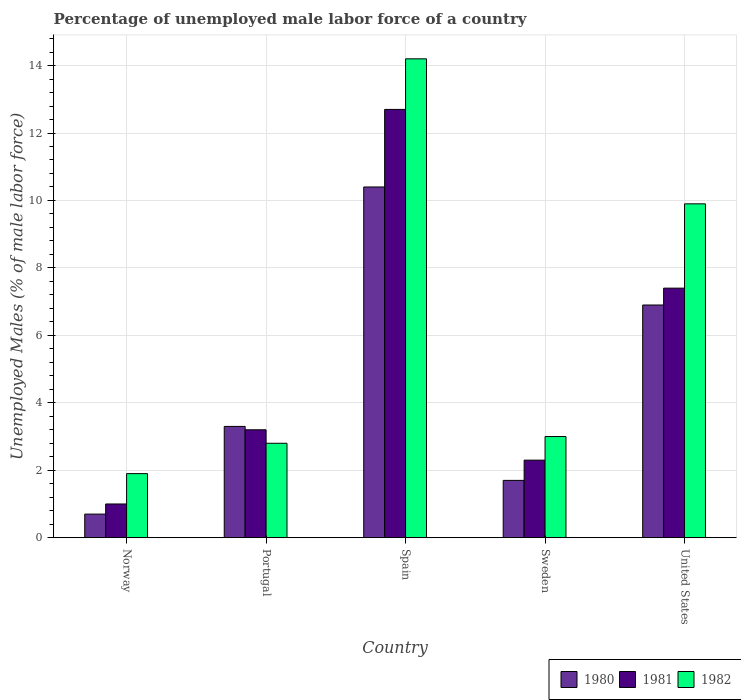How many bars are there on the 2nd tick from the right?
Your answer should be compact. 3. What is the label of the 3rd group of bars from the left?
Make the answer very short. Spain. In how many cases, is the number of bars for a given country not equal to the number of legend labels?
Offer a very short reply. 0. What is the percentage of unemployed male labor force in 1981 in Spain?
Give a very brief answer. 12.7. Across all countries, what is the maximum percentage of unemployed male labor force in 1982?
Your answer should be very brief. 14.2. Across all countries, what is the minimum percentage of unemployed male labor force in 1982?
Your answer should be compact. 1.9. In which country was the percentage of unemployed male labor force in 1981 maximum?
Offer a terse response. Spain. In which country was the percentage of unemployed male labor force in 1980 minimum?
Offer a very short reply. Norway. What is the total percentage of unemployed male labor force in 1982 in the graph?
Your answer should be very brief. 31.8. What is the difference between the percentage of unemployed male labor force in 1982 in Portugal and that in United States?
Your answer should be compact. -7.1. What is the difference between the percentage of unemployed male labor force in 1981 in Norway and the percentage of unemployed male labor force in 1982 in Sweden?
Give a very brief answer. -2. What is the average percentage of unemployed male labor force in 1980 per country?
Your answer should be very brief. 4.6. What is the difference between the percentage of unemployed male labor force of/in 1980 and percentage of unemployed male labor force of/in 1981 in Sweden?
Make the answer very short. -0.6. In how many countries, is the percentage of unemployed male labor force in 1982 greater than 2 %?
Your answer should be compact. 4. What is the ratio of the percentage of unemployed male labor force in 1980 in Spain to that in Sweden?
Your response must be concise. 6.12. Is the percentage of unemployed male labor force in 1981 in Sweden less than that in United States?
Make the answer very short. Yes. Is the difference between the percentage of unemployed male labor force in 1980 in Spain and United States greater than the difference between the percentage of unemployed male labor force in 1981 in Spain and United States?
Make the answer very short. No. What is the difference between the highest and the second highest percentage of unemployed male labor force in 1981?
Give a very brief answer. -9.5. What is the difference between the highest and the lowest percentage of unemployed male labor force in 1982?
Give a very brief answer. 12.3. In how many countries, is the percentage of unemployed male labor force in 1982 greater than the average percentage of unemployed male labor force in 1982 taken over all countries?
Your answer should be compact. 2. What does the 1st bar from the left in Spain represents?
Make the answer very short. 1980. How many bars are there?
Your answer should be very brief. 15. How many countries are there in the graph?
Your response must be concise. 5. Does the graph contain any zero values?
Your answer should be very brief. No. What is the title of the graph?
Keep it short and to the point. Percentage of unemployed male labor force of a country. Does "1987" appear as one of the legend labels in the graph?
Provide a short and direct response. No. What is the label or title of the X-axis?
Make the answer very short. Country. What is the label or title of the Y-axis?
Provide a short and direct response. Unemployed Males (% of male labor force). What is the Unemployed Males (% of male labor force) in 1980 in Norway?
Your answer should be very brief. 0.7. What is the Unemployed Males (% of male labor force) in 1981 in Norway?
Offer a terse response. 1. What is the Unemployed Males (% of male labor force) of 1982 in Norway?
Give a very brief answer. 1.9. What is the Unemployed Males (% of male labor force) in 1980 in Portugal?
Offer a very short reply. 3.3. What is the Unemployed Males (% of male labor force) in 1981 in Portugal?
Give a very brief answer. 3.2. What is the Unemployed Males (% of male labor force) of 1982 in Portugal?
Your answer should be very brief. 2.8. What is the Unemployed Males (% of male labor force) of 1980 in Spain?
Offer a terse response. 10.4. What is the Unemployed Males (% of male labor force) of 1981 in Spain?
Offer a very short reply. 12.7. What is the Unemployed Males (% of male labor force) of 1982 in Spain?
Your answer should be very brief. 14.2. What is the Unemployed Males (% of male labor force) in 1980 in Sweden?
Your answer should be compact. 1.7. What is the Unemployed Males (% of male labor force) in 1981 in Sweden?
Keep it short and to the point. 2.3. What is the Unemployed Males (% of male labor force) of 1982 in Sweden?
Your answer should be compact. 3. What is the Unemployed Males (% of male labor force) of 1980 in United States?
Keep it short and to the point. 6.9. What is the Unemployed Males (% of male labor force) in 1981 in United States?
Offer a very short reply. 7.4. What is the Unemployed Males (% of male labor force) in 1982 in United States?
Give a very brief answer. 9.9. Across all countries, what is the maximum Unemployed Males (% of male labor force) of 1980?
Offer a terse response. 10.4. Across all countries, what is the maximum Unemployed Males (% of male labor force) of 1981?
Your answer should be compact. 12.7. Across all countries, what is the maximum Unemployed Males (% of male labor force) in 1982?
Provide a succinct answer. 14.2. Across all countries, what is the minimum Unemployed Males (% of male labor force) in 1980?
Offer a terse response. 0.7. Across all countries, what is the minimum Unemployed Males (% of male labor force) of 1981?
Provide a succinct answer. 1. Across all countries, what is the minimum Unemployed Males (% of male labor force) in 1982?
Your answer should be very brief. 1.9. What is the total Unemployed Males (% of male labor force) of 1980 in the graph?
Keep it short and to the point. 23. What is the total Unemployed Males (% of male labor force) in 1981 in the graph?
Ensure brevity in your answer.  26.6. What is the total Unemployed Males (% of male labor force) of 1982 in the graph?
Ensure brevity in your answer.  31.8. What is the difference between the Unemployed Males (% of male labor force) of 1980 in Norway and that in Portugal?
Your answer should be very brief. -2.6. What is the difference between the Unemployed Males (% of male labor force) of 1981 in Norway and that in Portugal?
Give a very brief answer. -2.2. What is the difference between the Unemployed Males (% of male labor force) in 1982 in Norway and that in Portugal?
Give a very brief answer. -0.9. What is the difference between the Unemployed Males (% of male labor force) in 1980 in Norway and that in Spain?
Offer a terse response. -9.7. What is the difference between the Unemployed Males (% of male labor force) in 1981 in Norway and that in Spain?
Your answer should be very brief. -11.7. What is the difference between the Unemployed Males (% of male labor force) of 1982 in Norway and that in Spain?
Your answer should be very brief. -12.3. What is the difference between the Unemployed Males (% of male labor force) in 1980 in Norway and that in Sweden?
Offer a very short reply. -1. What is the difference between the Unemployed Males (% of male labor force) of 1982 in Norway and that in Sweden?
Provide a short and direct response. -1.1. What is the difference between the Unemployed Males (% of male labor force) in 1980 in Norway and that in United States?
Offer a very short reply. -6.2. What is the difference between the Unemployed Males (% of male labor force) in 1981 in Norway and that in United States?
Your answer should be very brief. -6.4. What is the difference between the Unemployed Males (% of male labor force) in 1982 in Norway and that in United States?
Ensure brevity in your answer.  -8. What is the difference between the Unemployed Males (% of male labor force) in 1980 in Portugal and that in Spain?
Your answer should be compact. -7.1. What is the difference between the Unemployed Males (% of male labor force) of 1981 in Portugal and that in Spain?
Your response must be concise. -9.5. What is the difference between the Unemployed Males (% of male labor force) in 1982 in Portugal and that in Sweden?
Provide a short and direct response. -0.2. What is the difference between the Unemployed Males (% of male labor force) in 1981 in Portugal and that in United States?
Give a very brief answer. -4.2. What is the difference between the Unemployed Males (% of male labor force) of 1982 in Portugal and that in United States?
Provide a short and direct response. -7.1. What is the difference between the Unemployed Males (% of male labor force) of 1982 in Spain and that in United States?
Offer a very short reply. 4.3. What is the difference between the Unemployed Males (% of male labor force) in 1982 in Sweden and that in United States?
Your answer should be compact. -6.9. What is the difference between the Unemployed Males (% of male labor force) of 1980 in Norway and the Unemployed Males (% of male labor force) of 1982 in Portugal?
Your response must be concise. -2.1. What is the difference between the Unemployed Males (% of male labor force) in 1981 in Norway and the Unemployed Males (% of male labor force) in 1982 in Portugal?
Your response must be concise. -1.8. What is the difference between the Unemployed Males (% of male labor force) in 1980 in Norway and the Unemployed Males (% of male labor force) in 1982 in Spain?
Keep it short and to the point. -13.5. What is the difference between the Unemployed Males (% of male labor force) of 1981 in Norway and the Unemployed Males (% of male labor force) of 1982 in Spain?
Provide a short and direct response. -13.2. What is the difference between the Unemployed Males (% of male labor force) in 1980 in Norway and the Unemployed Males (% of male labor force) in 1982 in Sweden?
Offer a very short reply. -2.3. What is the difference between the Unemployed Males (% of male labor force) of 1981 in Norway and the Unemployed Males (% of male labor force) of 1982 in Sweden?
Offer a very short reply. -2. What is the difference between the Unemployed Males (% of male labor force) of 1980 in Norway and the Unemployed Males (% of male labor force) of 1982 in United States?
Keep it short and to the point. -9.2. What is the difference between the Unemployed Males (% of male labor force) in 1980 in Portugal and the Unemployed Males (% of male labor force) in 1981 in Spain?
Your answer should be compact. -9.4. What is the difference between the Unemployed Males (% of male labor force) in 1980 in Portugal and the Unemployed Males (% of male labor force) in 1981 in Sweden?
Keep it short and to the point. 1. What is the difference between the Unemployed Males (% of male labor force) of 1980 in Portugal and the Unemployed Males (% of male labor force) of 1982 in Sweden?
Provide a short and direct response. 0.3. What is the difference between the Unemployed Males (% of male labor force) in 1981 in Portugal and the Unemployed Males (% of male labor force) in 1982 in Sweden?
Your answer should be compact. 0.2. What is the difference between the Unemployed Males (% of male labor force) in 1980 in Portugal and the Unemployed Males (% of male labor force) in 1981 in United States?
Give a very brief answer. -4.1. What is the difference between the Unemployed Males (% of male labor force) in 1980 in Portugal and the Unemployed Males (% of male labor force) in 1982 in United States?
Keep it short and to the point. -6.6. What is the difference between the Unemployed Males (% of male labor force) of 1981 in Portugal and the Unemployed Males (% of male labor force) of 1982 in United States?
Provide a short and direct response. -6.7. What is the difference between the Unemployed Males (% of male labor force) of 1980 in Spain and the Unemployed Males (% of male labor force) of 1982 in Sweden?
Your answer should be very brief. 7.4. What is the difference between the Unemployed Males (% of male labor force) of 1981 in Spain and the Unemployed Males (% of male labor force) of 1982 in Sweden?
Your response must be concise. 9.7. What is the difference between the Unemployed Males (% of male labor force) in 1980 in Spain and the Unemployed Males (% of male labor force) in 1981 in United States?
Offer a very short reply. 3. What is the difference between the Unemployed Males (% of male labor force) of 1980 in Sweden and the Unemployed Males (% of male labor force) of 1981 in United States?
Give a very brief answer. -5.7. What is the difference between the Unemployed Males (% of male labor force) in 1981 in Sweden and the Unemployed Males (% of male labor force) in 1982 in United States?
Your answer should be compact. -7.6. What is the average Unemployed Males (% of male labor force) in 1981 per country?
Your response must be concise. 5.32. What is the average Unemployed Males (% of male labor force) in 1982 per country?
Your response must be concise. 6.36. What is the difference between the Unemployed Males (% of male labor force) of 1980 and Unemployed Males (% of male labor force) of 1982 in Norway?
Give a very brief answer. -1.2. What is the difference between the Unemployed Males (% of male labor force) in 1981 and Unemployed Males (% of male labor force) in 1982 in Portugal?
Keep it short and to the point. 0.4. What is the difference between the Unemployed Males (% of male labor force) in 1980 and Unemployed Males (% of male labor force) in 1982 in Spain?
Keep it short and to the point. -3.8. What is the difference between the Unemployed Males (% of male labor force) in 1981 and Unemployed Males (% of male labor force) in 1982 in Spain?
Offer a very short reply. -1.5. What is the difference between the Unemployed Males (% of male labor force) of 1980 and Unemployed Males (% of male labor force) of 1981 in Sweden?
Your answer should be very brief. -0.6. What is the difference between the Unemployed Males (% of male labor force) of 1981 and Unemployed Males (% of male labor force) of 1982 in Sweden?
Your answer should be compact. -0.7. What is the difference between the Unemployed Males (% of male labor force) of 1980 and Unemployed Males (% of male labor force) of 1982 in United States?
Make the answer very short. -3. What is the difference between the Unemployed Males (% of male labor force) of 1981 and Unemployed Males (% of male labor force) of 1982 in United States?
Your answer should be compact. -2.5. What is the ratio of the Unemployed Males (% of male labor force) in 1980 in Norway to that in Portugal?
Provide a short and direct response. 0.21. What is the ratio of the Unemployed Males (% of male labor force) of 1981 in Norway to that in Portugal?
Make the answer very short. 0.31. What is the ratio of the Unemployed Males (% of male labor force) in 1982 in Norway to that in Portugal?
Your response must be concise. 0.68. What is the ratio of the Unemployed Males (% of male labor force) in 1980 in Norway to that in Spain?
Make the answer very short. 0.07. What is the ratio of the Unemployed Males (% of male labor force) in 1981 in Norway to that in Spain?
Your answer should be very brief. 0.08. What is the ratio of the Unemployed Males (% of male labor force) of 1982 in Norway to that in Spain?
Make the answer very short. 0.13. What is the ratio of the Unemployed Males (% of male labor force) of 1980 in Norway to that in Sweden?
Offer a very short reply. 0.41. What is the ratio of the Unemployed Males (% of male labor force) of 1981 in Norway to that in Sweden?
Your response must be concise. 0.43. What is the ratio of the Unemployed Males (% of male labor force) in 1982 in Norway to that in Sweden?
Make the answer very short. 0.63. What is the ratio of the Unemployed Males (% of male labor force) in 1980 in Norway to that in United States?
Make the answer very short. 0.1. What is the ratio of the Unemployed Males (% of male labor force) in 1981 in Norway to that in United States?
Offer a terse response. 0.14. What is the ratio of the Unemployed Males (% of male labor force) of 1982 in Norway to that in United States?
Offer a terse response. 0.19. What is the ratio of the Unemployed Males (% of male labor force) of 1980 in Portugal to that in Spain?
Make the answer very short. 0.32. What is the ratio of the Unemployed Males (% of male labor force) in 1981 in Portugal to that in Spain?
Offer a very short reply. 0.25. What is the ratio of the Unemployed Males (% of male labor force) of 1982 in Portugal to that in Spain?
Your response must be concise. 0.2. What is the ratio of the Unemployed Males (% of male labor force) in 1980 in Portugal to that in Sweden?
Ensure brevity in your answer.  1.94. What is the ratio of the Unemployed Males (% of male labor force) of 1981 in Portugal to that in Sweden?
Provide a short and direct response. 1.39. What is the ratio of the Unemployed Males (% of male labor force) of 1982 in Portugal to that in Sweden?
Provide a short and direct response. 0.93. What is the ratio of the Unemployed Males (% of male labor force) in 1980 in Portugal to that in United States?
Make the answer very short. 0.48. What is the ratio of the Unemployed Males (% of male labor force) of 1981 in Portugal to that in United States?
Your answer should be compact. 0.43. What is the ratio of the Unemployed Males (% of male labor force) of 1982 in Portugal to that in United States?
Keep it short and to the point. 0.28. What is the ratio of the Unemployed Males (% of male labor force) in 1980 in Spain to that in Sweden?
Give a very brief answer. 6.12. What is the ratio of the Unemployed Males (% of male labor force) in 1981 in Spain to that in Sweden?
Provide a short and direct response. 5.52. What is the ratio of the Unemployed Males (% of male labor force) of 1982 in Spain to that in Sweden?
Ensure brevity in your answer.  4.73. What is the ratio of the Unemployed Males (% of male labor force) of 1980 in Spain to that in United States?
Provide a short and direct response. 1.51. What is the ratio of the Unemployed Males (% of male labor force) of 1981 in Spain to that in United States?
Provide a short and direct response. 1.72. What is the ratio of the Unemployed Males (% of male labor force) in 1982 in Spain to that in United States?
Your answer should be very brief. 1.43. What is the ratio of the Unemployed Males (% of male labor force) of 1980 in Sweden to that in United States?
Your response must be concise. 0.25. What is the ratio of the Unemployed Males (% of male labor force) in 1981 in Sweden to that in United States?
Make the answer very short. 0.31. What is the ratio of the Unemployed Males (% of male labor force) in 1982 in Sweden to that in United States?
Offer a terse response. 0.3. What is the difference between the highest and the second highest Unemployed Males (% of male labor force) of 1980?
Ensure brevity in your answer.  3.5. What is the difference between the highest and the second highest Unemployed Males (% of male labor force) of 1981?
Your answer should be very brief. 5.3. What is the difference between the highest and the lowest Unemployed Males (% of male labor force) in 1981?
Offer a very short reply. 11.7. What is the difference between the highest and the lowest Unemployed Males (% of male labor force) in 1982?
Your response must be concise. 12.3. 